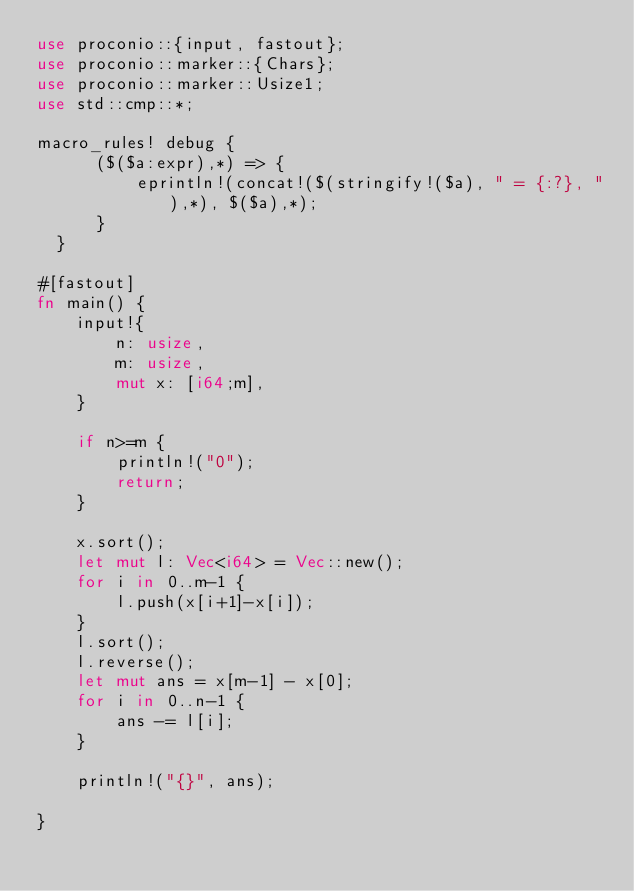<code> <loc_0><loc_0><loc_500><loc_500><_Rust_>use proconio::{input, fastout};
use proconio::marker::{Chars};
use proconio::marker::Usize1;
use std::cmp::*;

macro_rules! debug {
      ($($a:expr),*) => {
          eprintln!(concat!($(stringify!($a), " = {:?}, "),*), $($a),*);
      }
  }

#[fastout]
fn main() {
    input!{
        n: usize,
        m: usize,
        mut x: [i64;m],
    }

    if n>=m {
        println!("0");
        return;
    }

    x.sort();
    let mut l: Vec<i64> = Vec::new();
    for i in 0..m-1 {
        l.push(x[i+1]-x[i]);
    }
    l.sort();
    l.reverse();
    let mut ans = x[m-1] - x[0];
    for i in 0..n-1 {
        ans -= l[i];
    }

    println!("{}", ans);

}
</code> 